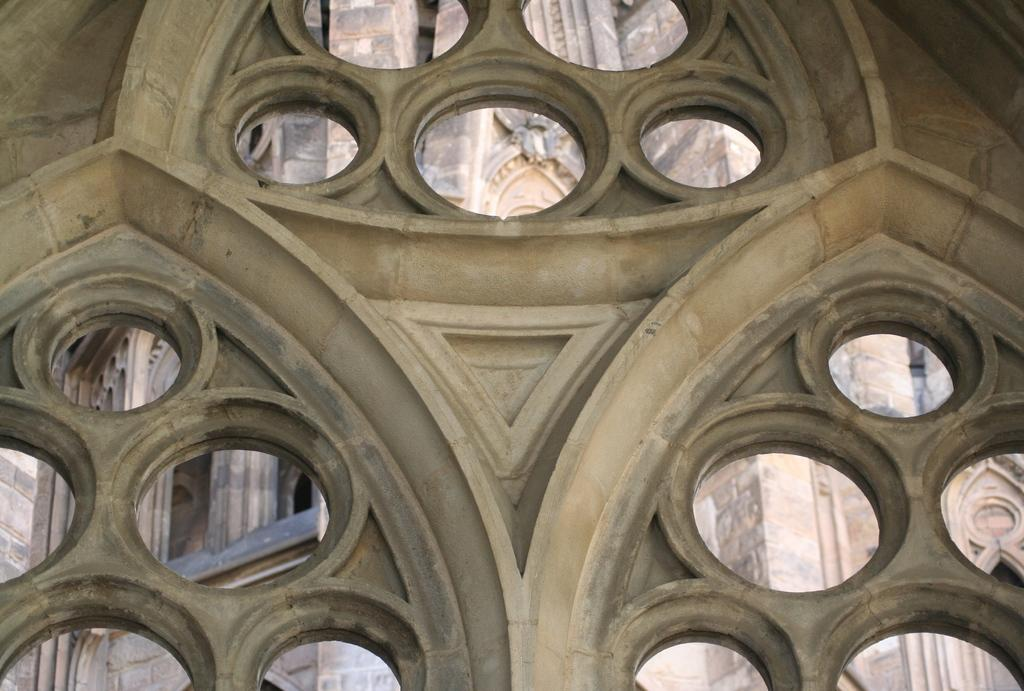What type of structure is visible in the image? There is an arch in the image. What material is the arch made of? The arch is made of stone. How close is the view of the arch in the image? The image provides a close view of the arch. How many holes can be seen in the arch in the image? There are no holes visible in the arch in the image. What type of birth is depicted in the image? There is no birth depicted in the image; it features an arch made of stone. 